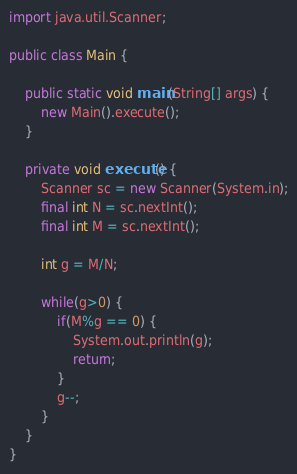Convert code to text. <code><loc_0><loc_0><loc_500><loc_500><_Java_>import java.util.Scanner;

public class Main {

	public static void main(String[] args) {
		new Main().execute();
	}

	private void execute() {
		Scanner sc = new Scanner(System.in);
		final int N = sc.nextInt();
		final int M = sc.nextInt();
		
		int g = M/N;
		
		while(g>0) {
			if(M%g == 0) {
				System.out.println(g);
				return;
			}
			g--;
		}
	}
}
</code> 